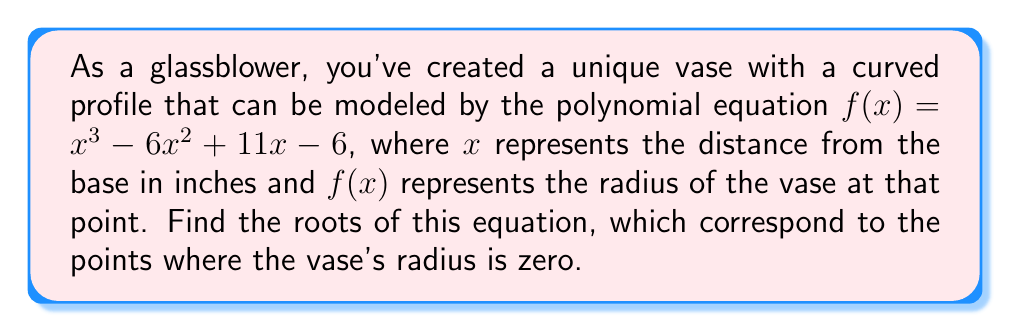Show me your answer to this math problem. To find the roots of the polynomial equation $f(x) = x^3 - 6x^2 + 11x - 6$, we need to factor the polynomial. Let's approach this step-by-step:

1) First, let's check if there are any rational roots using the rational root theorem. The possible rational roots are the factors of the constant term (6): $\pm 1, \pm 2, \pm 3, \pm 6$.

2) Testing these values, we find that $f(1) = 0$. So, $(x-1)$ is a factor.

3) We can use polynomial long division to divide $f(x)$ by $(x-1)$:

   $x^3 - 6x^2 + 11x - 6 = (x-1)(x^2 - 5x + 6)$

4) Now we need to factor the quadratic term $x^2 - 5x + 6$. We can do this by finding two numbers that multiply to give 6 and add to give -5. These numbers are -2 and -3.

5) Therefore, $x^2 - 5x + 6 = (x-2)(x-3)$

6) Combining all factors, we get:

   $f(x) = (x-1)(x-2)(x-3)$

7) The roots of the equation are the values that make each factor equal to zero. So, the roots are $x = 1$, $x = 2$, and $x = 3$.

These roots represent the points where the radius of the vase is zero, corresponding to the top and bottom of the vase, and potentially a point where the vase narrows to a point in the middle.
Answer: The roots of the equation are $x = 1$, $x = 2$, and $x = 3$. 